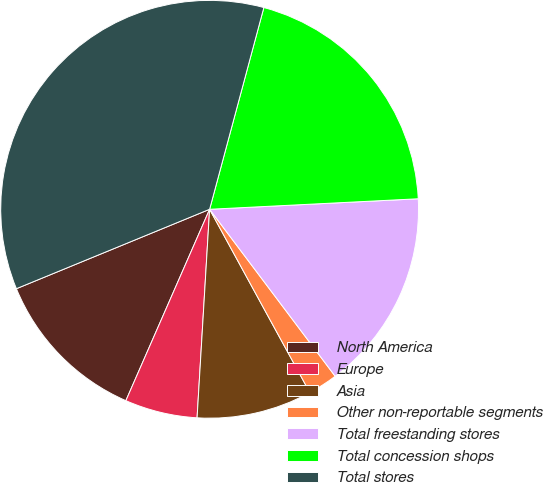Convert chart. <chart><loc_0><loc_0><loc_500><loc_500><pie_chart><fcel>North America<fcel>Europe<fcel>Asia<fcel>Other non-reportable segments<fcel>Total freestanding stores<fcel>Total concession shops<fcel>Total stores<nl><fcel>12.23%<fcel>5.61%<fcel>8.92%<fcel>2.3%<fcel>15.54%<fcel>20.02%<fcel>35.39%<nl></chart> 